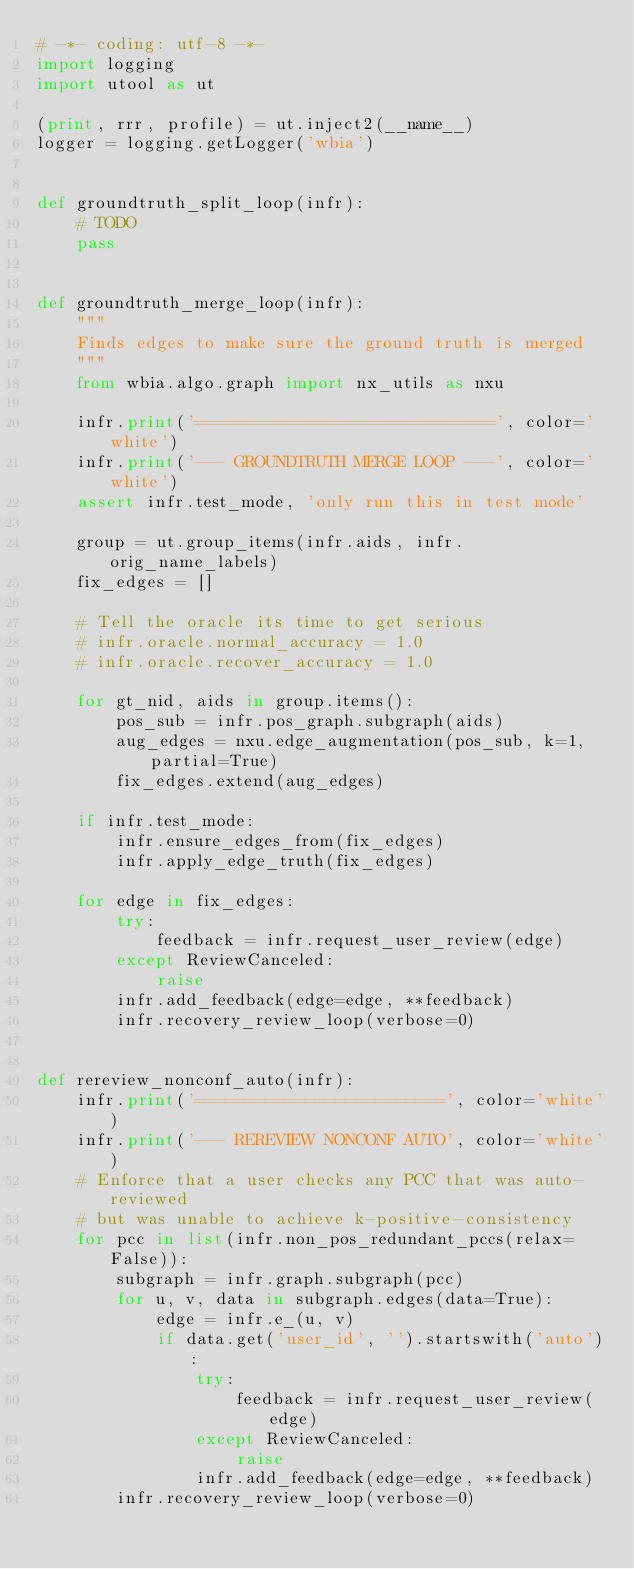Convert code to text. <code><loc_0><loc_0><loc_500><loc_500><_Python_># -*- coding: utf-8 -*-
import logging
import utool as ut

(print, rrr, profile) = ut.inject2(__name__)
logger = logging.getLogger('wbia')


def groundtruth_split_loop(infr):
    # TODO
    pass


def groundtruth_merge_loop(infr):
    """
    Finds edges to make sure the ground truth is merged
    """
    from wbia.algo.graph import nx_utils as nxu

    infr.print('==============================', color='white')
    infr.print('--- GROUNDTRUTH MERGE LOOP ---', color='white')
    assert infr.test_mode, 'only run this in test mode'

    group = ut.group_items(infr.aids, infr.orig_name_labels)
    fix_edges = []

    # Tell the oracle its time to get serious
    # infr.oracle.normal_accuracy = 1.0
    # infr.oracle.recover_accuracy = 1.0

    for gt_nid, aids in group.items():
        pos_sub = infr.pos_graph.subgraph(aids)
        aug_edges = nxu.edge_augmentation(pos_sub, k=1, partial=True)
        fix_edges.extend(aug_edges)

    if infr.test_mode:
        infr.ensure_edges_from(fix_edges)
        infr.apply_edge_truth(fix_edges)

    for edge in fix_edges:
        try:
            feedback = infr.request_user_review(edge)
        except ReviewCanceled:
            raise
        infr.add_feedback(edge=edge, **feedback)
        infr.recovery_review_loop(verbose=0)


def rereview_nonconf_auto(infr):
    infr.print('=========================', color='white')
    infr.print('--- REREVIEW NONCONF AUTO', color='white')
    # Enforce that a user checks any PCC that was auto-reviewed
    # but was unable to achieve k-positive-consistency
    for pcc in list(infr.non_pos_redundant_pccs(relax=False)):
        subgraph = infr.graph.subgraph(pcc)
        for u, v, data in subgraph.edges(data=True):
            edge = infr.e_(u, v)
            if data.get('user_id', '').startswith('auto'):
                try:
                    feedback = infr.request_user_review(edge)
                except ReviewCanceled:
                    raise
                infr.add_feedback(edge=edge, **feedback)
        infr.recovery_review_loop(verbose=0)

</code> 